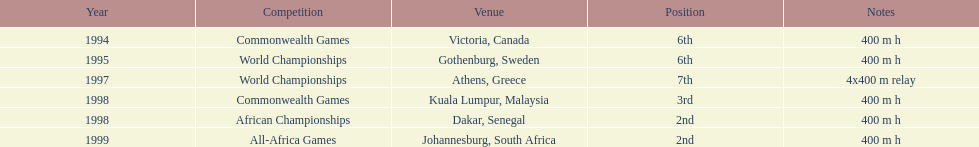What venue came before gothenburg, sweden? Victoria, Canada. 